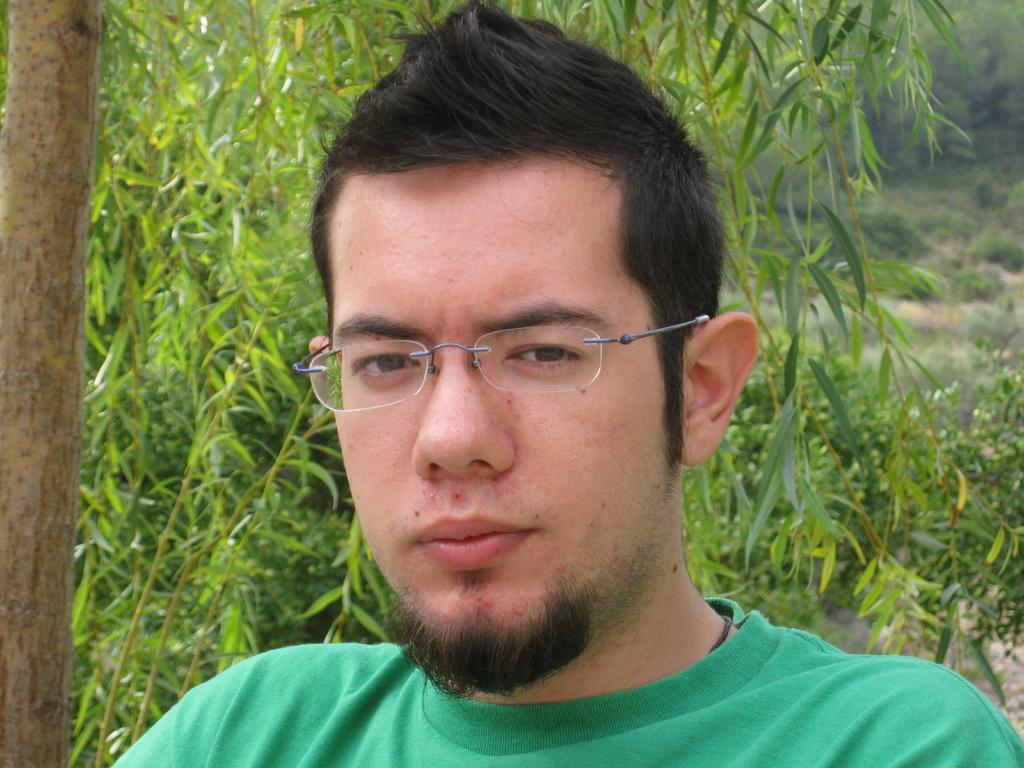Who is present in the image? There is a man in the image. What is the man wearing? The man is wearing a green T-shirt and specs. What can be seen to the left of the man? There is a tree to the left of the man. What is visible in the background of the image? There are plants and trees in the background of the image. What letter is the frog holding in the image? There is no frog present in the image, and therefore no letter can be held by a frog. 